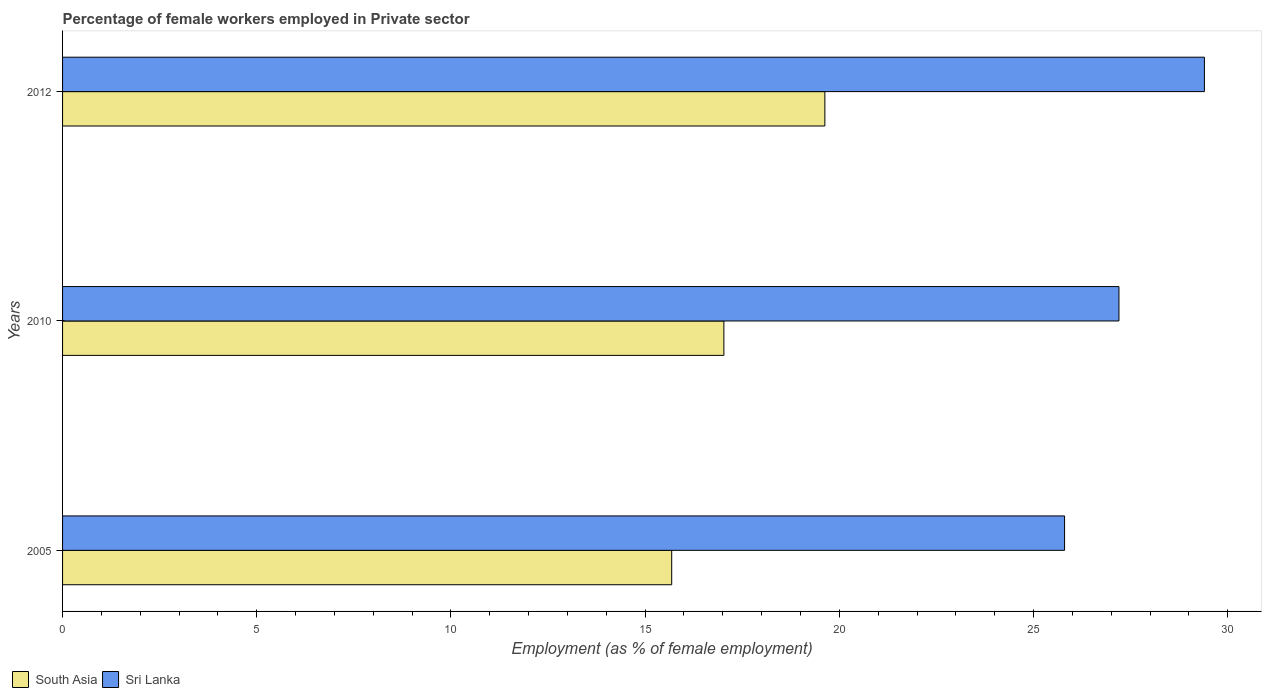How many groups of bars are there?
Provide a short and direct response. 3. Are the number of bars per tick equal to the number of legend labels?
Your answer should be compact. Yes. Are the number of bars on each tick of the Y-axis equal?
Provide a short and direct response. Yes. How many bars are there on the 1st tick from the bottom?
Ensure brevity in your answer.  2. What is the label of the 3rd group of bars from the top?
Provide a succinct answer. 2005. In how many cases, is the number of bars for a given year not equal to the number of legend labels?
Keep it short and to the point. 0. What is the percentage of females employed in Private sector in Sri Lanka in 2010?
Provide a short and direct response. 27.2. Across all years, what is the maximum percentage of females employed in Private sector in South Asia?
Offer a very short reply. 19.63. Across all years, what is the minimum percentage of females employed in Private sector in South Asia?
Your response must be concise. 15.68. In which year was the percentage of females employed in Private sector in Sri Lanka minimum?
Provide a succinct answer. 2005. What is the total percentage of females employed in Private sector in Sri Lanka in the graph?
Your response must be concise. 82.4. What is the difference between the percentage of females employed in Private sector in Sri Lanka in 2005 and that in 2010?
Your response must be concise. -1.4. What is the difference between the percentage of females employed in Private sector in Sri Lanka in 2005 and the percentage of females employed in Private sector in South Asia in 2012?
Keep it short and to the point. 6.17. What is the average percentage of females employed in Private sector in South Asia per year?
Your answer should be very brief. 17.45. In the year 2012, what is the difference between the percentage of females employed in Private sector in South Asia and percentage of females employed in Private sector in Sri Lanka?
Give a very brief answer. -9.77. What is the ratio of the percentage of females employed in Private sector in Sri Lanka in 2005 to that in 2012?
Your answer should be compact. 0.88. Is the percentage of females employed in Private sector in South Asia in 2010 less than that in 2012?
Give a very brief answer. Yes. What is the difference between the highest and the second highest percentage of females employed in Private sector in South Asia?
Provide a short and direct response. 2.6. What is the difference between the highest and the lowest percentage of females employed in Private sector in Sri Lanka?
Provide a short and direct response. 3.6. In how many years, is the percentage of females employed in Private sector in Sri Lanka greater than the average percentage of females employed in Private sector in Sri Lanka taken over all years?
Provide a short and direct response. 1. What does the 2nd bar from the top in 2012 represents?
Keep it short and to the point. South Asia. What does the 2nd bar from the bottom in 2012 represents?
Your response must be concise. Sri Lanka. Are all the bars in the graph horizontal?
Your answer should be very brief. Yes. Are the values on the major ticks of X-axis written in scientific E-notation?
Keep it short and to the point. No. Does the graph contain any zero values?
Keep it short and to the point. No. Does the graph contain grids?
Make the answer very short. No. How many legend labels are there?
Provide a short and direct response. 2. How are the legend labels stacked?
Offer a terse response. Horizontal. What is the title of the graph?
Offer a very short reply. Percentage of female workers employed in Private sector. What is the label or title of the X-axis?
Provide a succinct answer. Employment (as % of female employment). What is the label or title of the Y-axis?
Keep it short and to the point. Years. What is the Employment (as % of female employment) in South Asia in 2005?
Provide a short and direct response. 15.68. What is the Employment (as % of female employment) of Sri Lanka in 2005?
Provide a short and direct response. 25.8. What is the Employment (as % of female employment) in South Asia in 2010?
Your answer should be compact. 17.03. What is the Employment (as % of female employment) in Sri Lanka in 2010?
Offer a very short reply. 27.2. What is the Employment (as % of female employment) of South Asia in 2012?
Keep it short and to the point. 19.63. What is the Employment (as % of female employment) in Sri Lanka in 2012?
Make the answer very short. 29.4. Across all years, what is the maximum Employment (as % of female employment) in South Asia?
Offer a very short reply. 19.63. Across all years, what is the maximum Employment (as % of female employment) in Sri Lanka?
Your answer should be very brief. 29.4. Across all years, what is the minimum Employment (as % of female employment) in South Asia?
Make the answer very short. 15.68. Across all years, what is the minimum Employment (as % of female employment) of Sri Lanka?
Provide a succinct answer. 25.8. What is the total Employment (as % of female employment) in South Asia in the graph?
Your response must be concise. 52.34. What is the total Employment (as % of female employment) of Sri Lanka in the graph?
Give a very brief answer. 82.4. What is the difference between the Employment (as % of female employment) of South Asia in 2005 and that in 2010?
Your response must be concise. -1.34. What is the difference between the Employment (as % of female employment) in Sri Lanka in 2005 and that in 2010?
Make the answer very short. -1.4. What is the difference between the Employment (as % of female employment) of South Asia in 2005 and that in 2012?
Your answer should be very brief. -3.94. What is the difference between the Employment (as % of female employment) in Sri Lanka in 2005 and that in 2012?
Your response must be concise. -3.6. What is the difference between the Employment (as % of female employment) of South Asia in 2010 and that in 2012?
Your answer should be very brief. -2.6. What is the difference between the Employment (as % of female employment) in South Asia in 2005 and the Employment (as % of female employment) in Sri Lanka in 2010?
Keep it short and to the point. -11.52. What is the difference between the Employment (as % of female employment) in South Asia in 2005 and the Employment (as % of female employment) in Sri Lanka in 2012?
Your answer should be very brief. -13.72. What is the difference between the Employment (as % of female employment) in South Asia in 2010 and the Employment (as % of female employment) in Sri Lanka in 2012?
Your answer should be very brief. -12.37. What is the average Employment (as % of female employment) of South Asia per year?
Make the answer very short. 17.45. What is the average Employment (as % of female employment) of Sri Lanka per year?
Keep it short and to the point. 27.47. In the year 2005, what is the difference between the Employment (as % of female employment) of South Asia and Employment (as % of female employment) of Sri Lanka?
Your response must be concise. -10.12. In the year 2010, what is the difference between the Employment (as % of female employment) in South Asia and Employment (as % of female employment) in Sri Lanka?
Your answer should be very brief. -10.17. In the year 2012, what is the difference between the Employment (as % of female employment) of South Asia and Employment (as % of female employment) of Sri Lanka?
Make the answer very short. -9.77. What is the ratio of the Employment (as % of female employment) of South Asia in 2005 to that in 2010?
Make the answer very short. 0.92. What is the ratio of the Employment (as % of female employment) of Sri Lanka in 2005 to that in 2010?
Your answer should be very brief. 0.95. What is the ratio of the Employment (as % of female employment) of South Asia in 2005 to that in 2012?
Your answer should be very brief. 0.8. What is the ratio of the Employment (as % of female employment) of Sri Lanka in 2005 to that in 2012?
Ensure brevity in your answer.  0.88. What is the ratio of the Employment (as % of female employment) of South Asia in 2010 to that in 2012?
Give a very brief answer. 0.87. What is the ratio of the Employment (as % of female employment) in Sri Lanka in 2010 to that in 2012?
Ensure brevity in your answer.  0.93. What is the difference between the highest and the second highest Employment (as % of female employment) of South Asia?
Provide a short and direct response. 2.6. What is the difference between the highest and the lowest Employment (as % of female employment) of South Asia?
Keep it short and to the point. 3.94. 